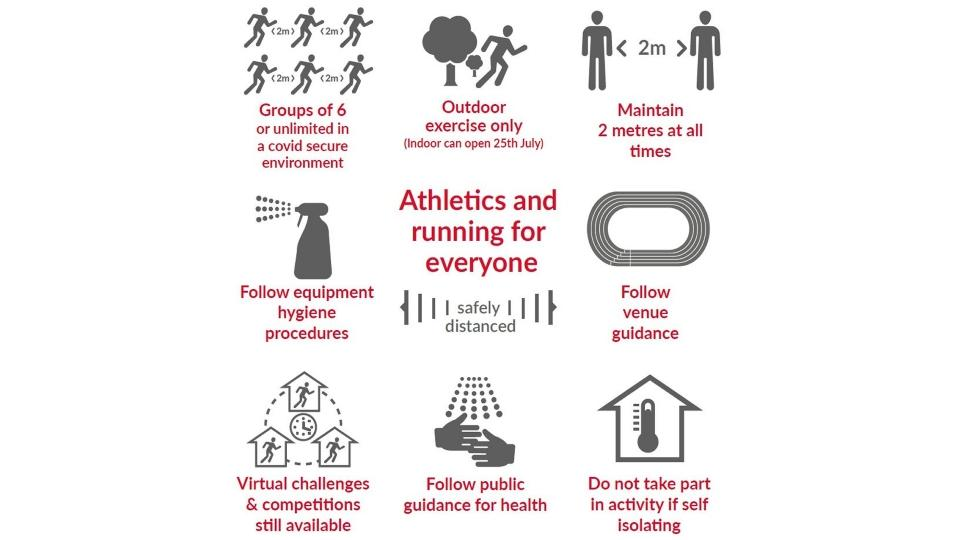Highlight a few significant elements in this photo. There are 8 listed guidelines for athletes in the info graphic. Athletes should refrain from participating in competition if they are self-isolating. It is imperative that athletes adhere to equipment hygiene procedures as outlined by guidelines to ensure the safe and proper use of equipment. 